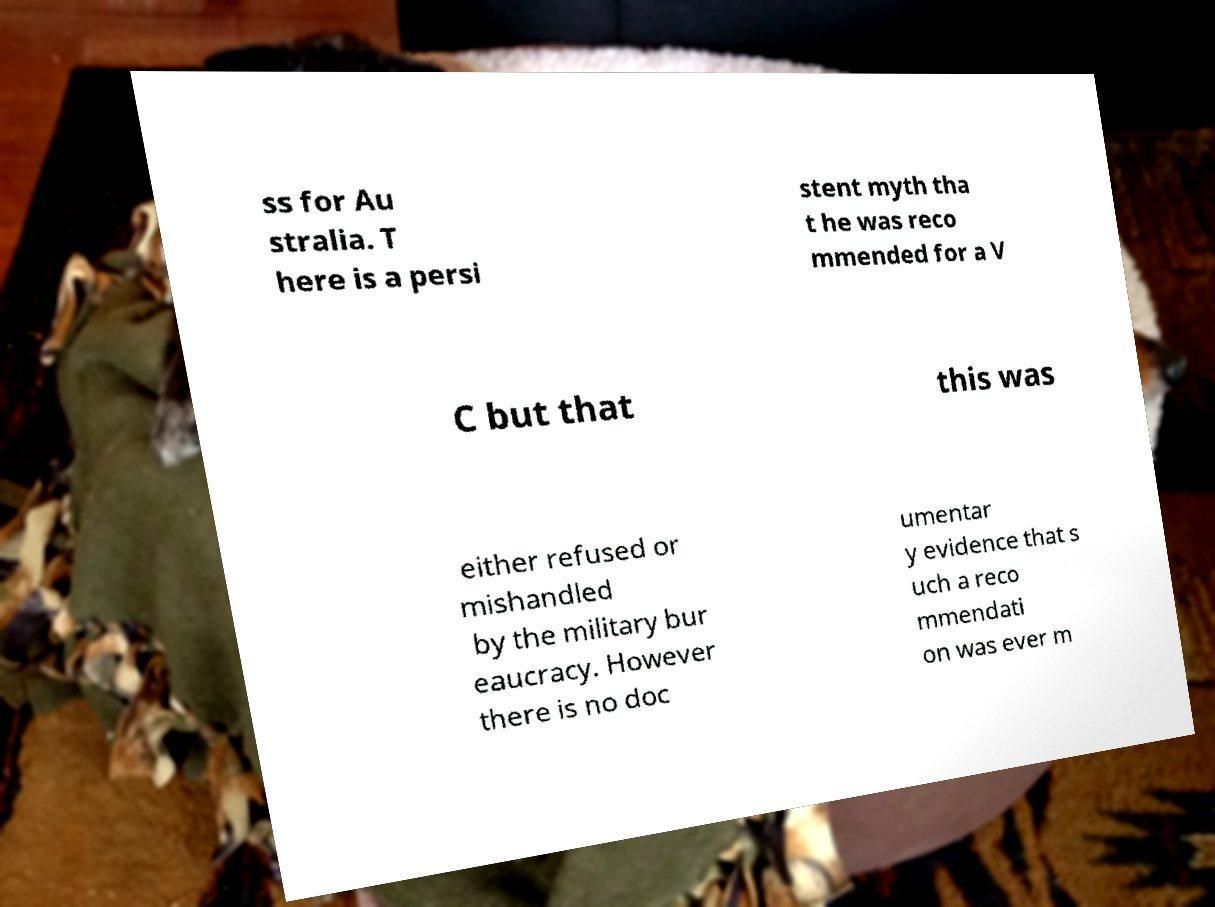There's text embedded in this image that I need extracted. Can you transcribe it verbatim? ss for Au stralia. T here is a persi stent myth tha t he was reco mmended for a V C but that this was either refused or mishandled by the military bur eaucracy. However there is no doc umentar y evidence that s uch a reco mmendati on was ever m 